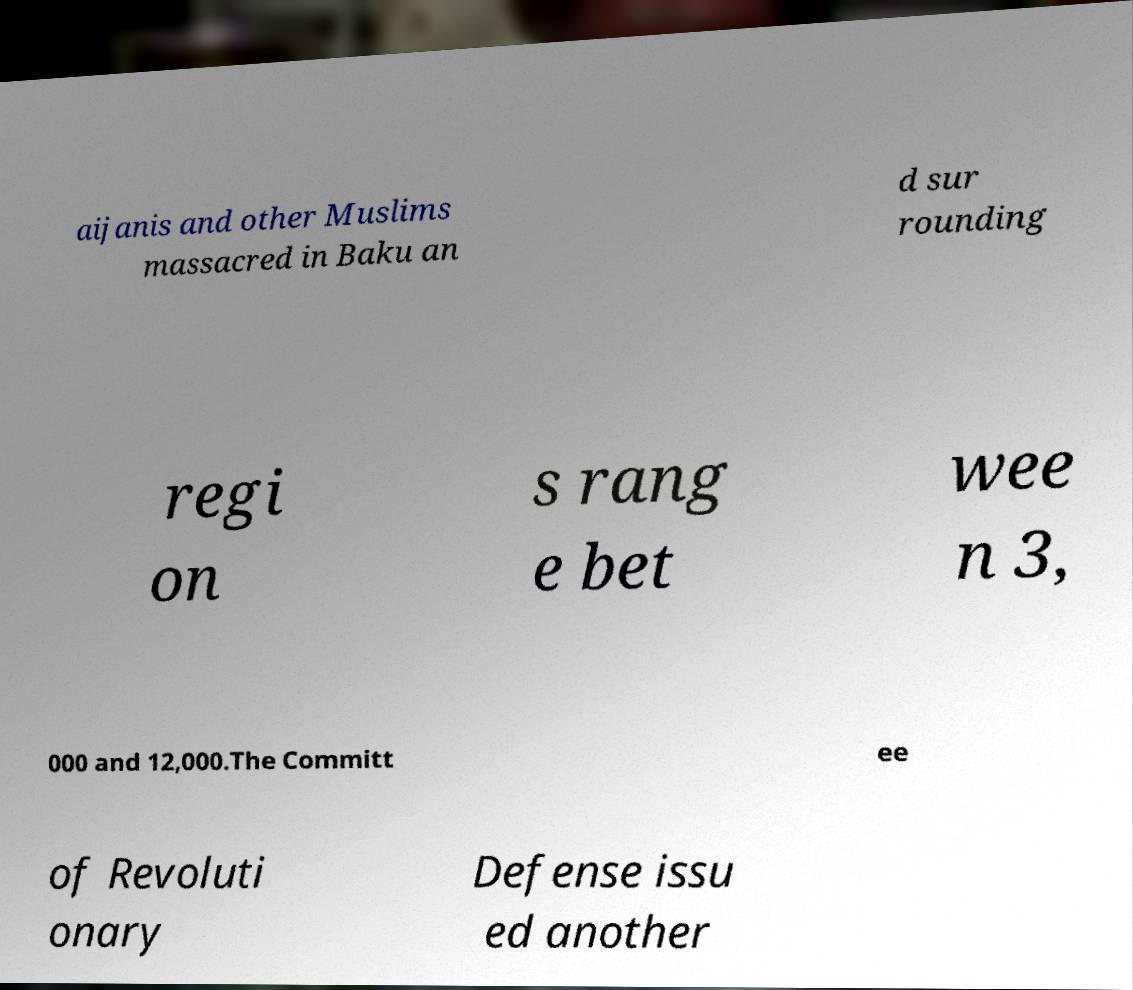Could you extract and type out the text from this image? aijanis and other Muslims massacred in Baku an d sur rounding regi on s rang e bet wee n 3, 000 and 12,000.The Committ ee of Revoluti onary Defense issu ed another 